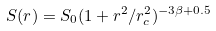Convert formula to latex. <formula><loc_0><loc_0><loc_500><loc_500>S ( r ) = S _ { 0 } ( 1 + r ^ { 2 } / r _ { c } ^ { 2 } ) ^ { - 3 \beta + 0 . 5 }</formula> 